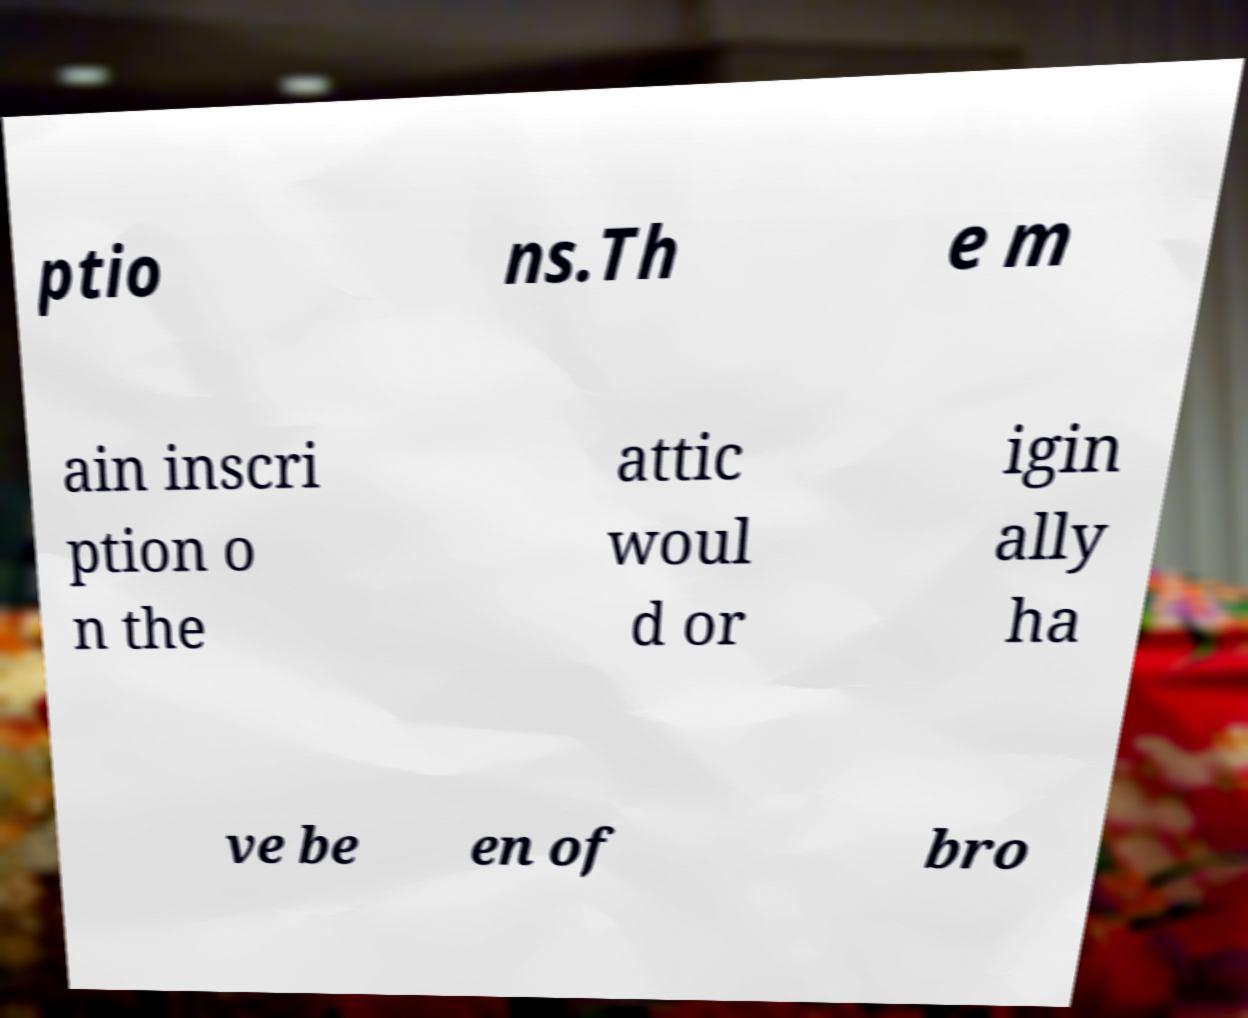Could you assist in decoding the text presented in this image and type it out clearly? ptio ns.Th e m ain inscri ption o n the attic woul d or igin ally ha ve be en of bro 